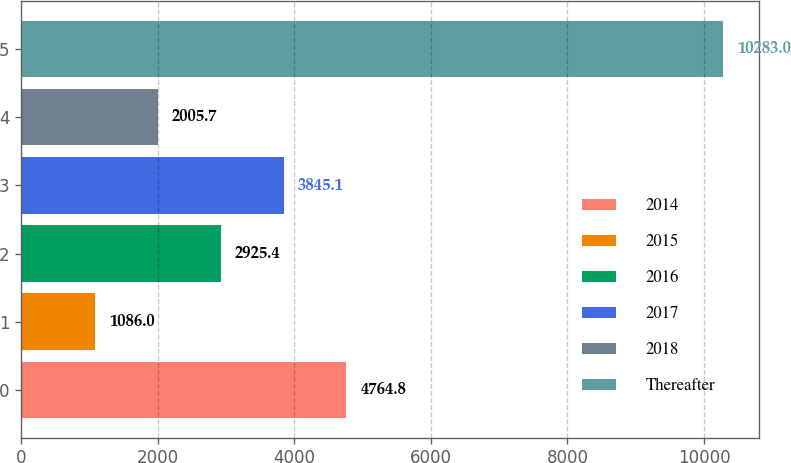<chart> <loc_0><loc_0><loc_500><loc_500><bar_chart><fcel>2014<fcel>2015<fcel>2016<fcel>2017<fcel>2018<fcel>Thereafter<nl><fcel>4764.8<fcel>1086<fcel>2925.4<fcel>3845.1<fcel>2005.7<fcel>10283<nl></chart> 